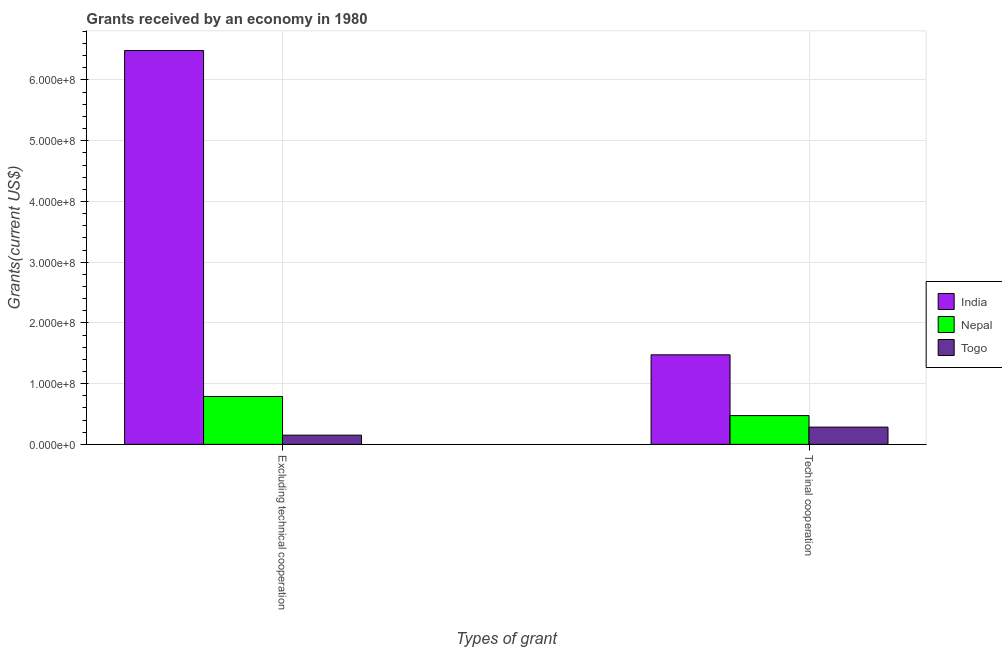How many different coloured bars are there?
Give a very brief answer. 3. Are the number of bars per tick equal to the number of legend labels?
Offer a terse response. Yes. Are the number of bars on each tick of the X-axis equal?
Provide a short and direct response. Yes. How many bars are there on the 1st tick from the right?
Offer a very short reply. 3. What is the label of the 2nd group of bars from the left?
Ensure brevity in your answer.  Techinal cooperation. What is the amount of grants received(including technical cooperation) in Togo?
Provide a succinct answer. 2.84e+07. Across all countries, what is the maximum amount of grants received(including technical cooperation)?
Provide a short and direct response. 1.47e+08. Across all countries, what is the minimum amount of grants received(excluding technical cooperation)?
Offer a very short reply. 1.51e+07. In which country was the amount of grants received(excluding technical cooperation) minimum?
Keep it short and to the point. Togo. What is the total amount of grants received(including technical cooperation) in the graph?
Make the answer very short. 2.23e+08. What is the difference between the amount of grants received(excluding technical cooperation) in India and that in Nepal?
Offer a very short reply. 5.70e+08. What is the difference between the amount of grants received(including technical cooperation) in Nepal and the amount of grants received(excluding technical cooperation) in India?
Your answer should be compact. -6.01e+08. What is the average amount of grants received(excluding technical cooperation) per country?
Provide a short and direct response. 2.47e+08. What is the difference between the amount of grants received(excluding technical cooperation) and amount of grants received(including technical cooperation) in Nepal?
Your answer should be compact. 3.14e+07. What is the ratio of the amount of grants received(including technical cooperation) in India to that in Nepal?
Give a very brief answer. 3.11. What does the 2nd bar from the left in Techinal cooperation represents?
Make the answer very short. Nepal. What does the 2nd bar from the right in Techinal cooperation represents?
Make the answer very short. Nepal. Are all the bars in the graph horizontal?
Your answer should be compact. No. Are the values on the major ticks of Y-axis written in scientific E-notation?
Offer a very short reply. Yes. How many legend labels are there?
Offer a terse response. 3. What is the title of the graph?
Your answer should be very brief. Grants received by an economy in 1980. What is the label or title of the X-axis?
Keep it short and to the point. Types of grant. What is the label or title of the Y-axis?
Your response must be concise. Grants(current US$). What is the Grants(current US$) in India in Excluding technical cooperation?
Provide a short and direct response. 6.49e+08. What is the Grants(current US$) of Nepal in Excluding technical cooperation?
Make the answer very short. 7.88e+07. What is the Grants(current US$) in Togo in Excluding technical cooperation?
Your answer should be compact. 1.51e+07. What is the Grants(current US$) of India in Techinal cooperation?
Keep it short and to the point. 1.47e+08. What is the Grants(current US$) of Nepal in Techinal cooperation?
Provide a short and direct response. 4.74e+07. What is the Grants(current US$) of Togo in Techinal cooperation?
Offer a terse response. 2.84e+07. Across all Types of grant, what is the maximum Grants(current US$) in India?
Keep it short and to the point. 6.49e+08. Across all Types of grant, what is the maximum Grants(current US$) of Nepal?
Provide a short and direct response. 7.88e+07. Across all Types of grant, what is the maximum Grants(current US$) of Togo?
Your response must be concise. 2.84e+07. Across all Types of grant, what is the minimum Grants(current US$) of India?
Give a very brief answer. 1.47e+08. Across all Types of grant, what is the minimum Grants(current US$) in Nepal?
Offer a terse response. 4.74e+07. Across all Types of grant, what is the minimum Grants(current US$) of Togo?
Give a very brief answer. 1.51e+07. What is the total Grants(current US$) in India in the graph?
Provide a succinct answer. 7.96e+08. What is the total Grants(current US$) of Nepal in the graph?
Ensure brevity in your answer.  1.26e+08. What is the total Grants(current US$) of Togo in the graph?
Keep it short and to the point. 4.35e+07. What is the difference between the Grants(current US$) of India in Excluding technical cooperation and that in Techinal cooperation?
Your answer should be very brief. 5.01e+08. What is the difference between the Grants(current US$) of Nepal in Excluding technical cooperation and that in Techinal cooperation?
Offer a very short reply. 3.14e+07. What is the difference between the Grants(current US$) in Togo in Excluding technical cooperation and that in Techinal cooperation?
Give a very brief answer. -1.32e+07. What is the difference between the Grants(current US$) in India in Excluding technical cooperation and the Grants(current US$) in Nepal in Techinal cooperation?
Provide a short and direct response. 6.01e+08. What is the difference between the Grants(current US$) in India in Excluding technical cooperation and the Grants(current US$) in Togo in Techinal cooperation?
Your answer should be very brief. 6.20e+08. What is the difference between the Grants(current US$) of Nepal in Excluding technical cooperation and the Grants(current US$) of Togo in Techinal cooperation?
Your answer should be very brief. 5.04e+07. What is the average Grants(current US$) of India per Types of grant?
Keep it short and to the point. 3.98e+08. What is the average Grants(current US$) in Nepal per Types of grant?
Your answer should be compact. 6.31e+07. What is the average Grants(current US$) of Togo per Types of grant?
Provide a succinct answer. 2.18e+07. What is the difference between the Grants(current US$) in India and Grants(current US$) in Nepal in Excluding technical cooperation?
Offer a terse response. 5.70e+08. What is the difference between the Grants(current US$) of India and Grants(current US$) of Togo in Excluding technical cooperation?
Give a very brief answer. 6.33e+08. What is the difference between the Grants(current US$) in Nepal and Grants(current US$) in Togo in Excluding technical cooperation?
Your response must be concise. 6.37e+07. What is the difference between the Grants(current US$) in India and Grants(current US$) in Nepal in Techinal cooperation?
Provide a short and direct response. 1.00e+08. What is the difference between the Grants(current US$) of India and Grants(current US$) of Togo in Techinal cooperation?
Keep it short and to the point. 1.19e+08. What is the difference between the Grants(current US$) of Nepal and Grants(current US$) of Togo in Techinal cooperation?
Provide a short and direct response. 1.90e+07. What is the ratio of the Grants(current US$) of India in Excluding technical cooperation to that in Techinal cooperation?
Provide a succinct answer. 4.4. What is the ratio of the Grants(current US$) of Nepal in Excluding technical cooperation to that in Techinal cooperation?
Offer a terse response. 1.66. What is the ratio of the Grants(current US$) of Togo in Excluding technical cooperation to that in Techinal cooperation?
Offer a terse response. 0.53. What is the difference between the highest and the second highest Grants(current US$) in India?
Provide a succinct answer. 5.01e+08. What is the difference between the highest and the second highest Grants(current US$) in Nepal?
Your answer should be compact. 3.14e+07. What is the difference between the highest and the second highest Grants(current US$) of Togo?
Keep it short and to the point. 1.32e+07. What is the difference between the highest and the lowest Grants(current US$) in India?
Give a very brief answer. 5.01e+08. What is the difference between the highest and the lowest Grants(current US$) in Nepal?
Ensure brevity in your answer.  3.14e+07. What is the difference between the highest and the lowest Grants(current US$) of Togo?
Keep it short and to the point. 1.32e+07. 